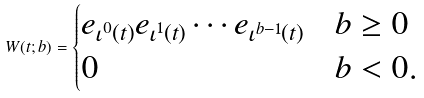<formula> <loc_0><loc_0><loc_500><loc_500>W ( t ; b ) = \begin{cases} e _ { \iota ^ { 0 } ( t ) } e _ { \iota ^ { 1 } ( t ) } \cdots e _ { \iota ^ { b - 1 } ( t ) } & b \geq 0 \\ 0 & b < 0 . \end{cases}</formula> 